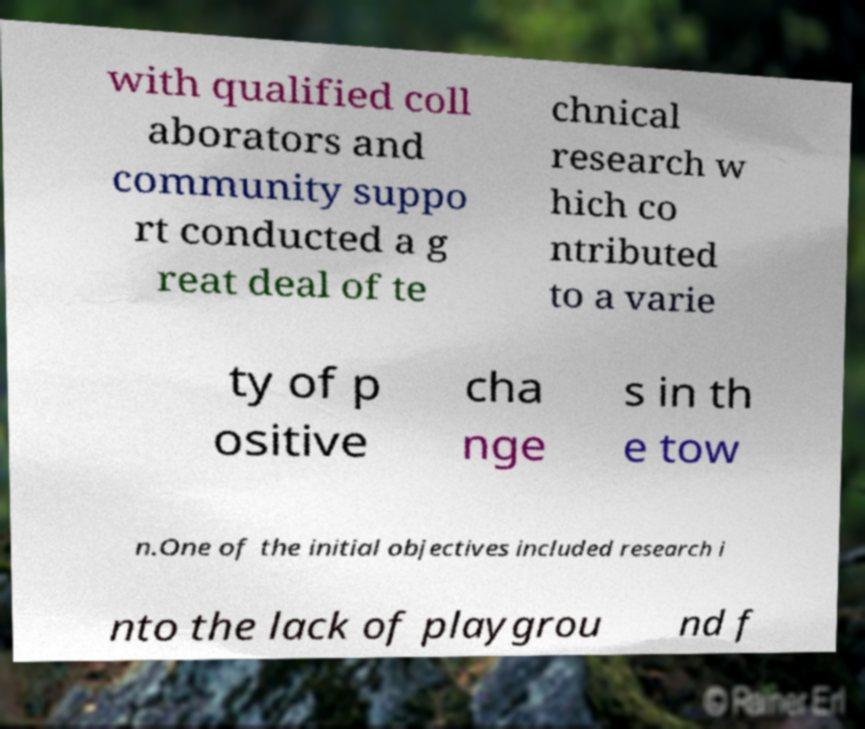Can you read and provide the text displayed in the image?This photo seems to have some interesting text. Can you extract and type it out for me? with qualified coll aborators and community suppo rt conducted a g reat deal of te chnical research w hich co ntributed to a varie ty of p ositive cha nge s in th e tow n.One of the initial objectives included research i nto the lack of playgrou nd f 